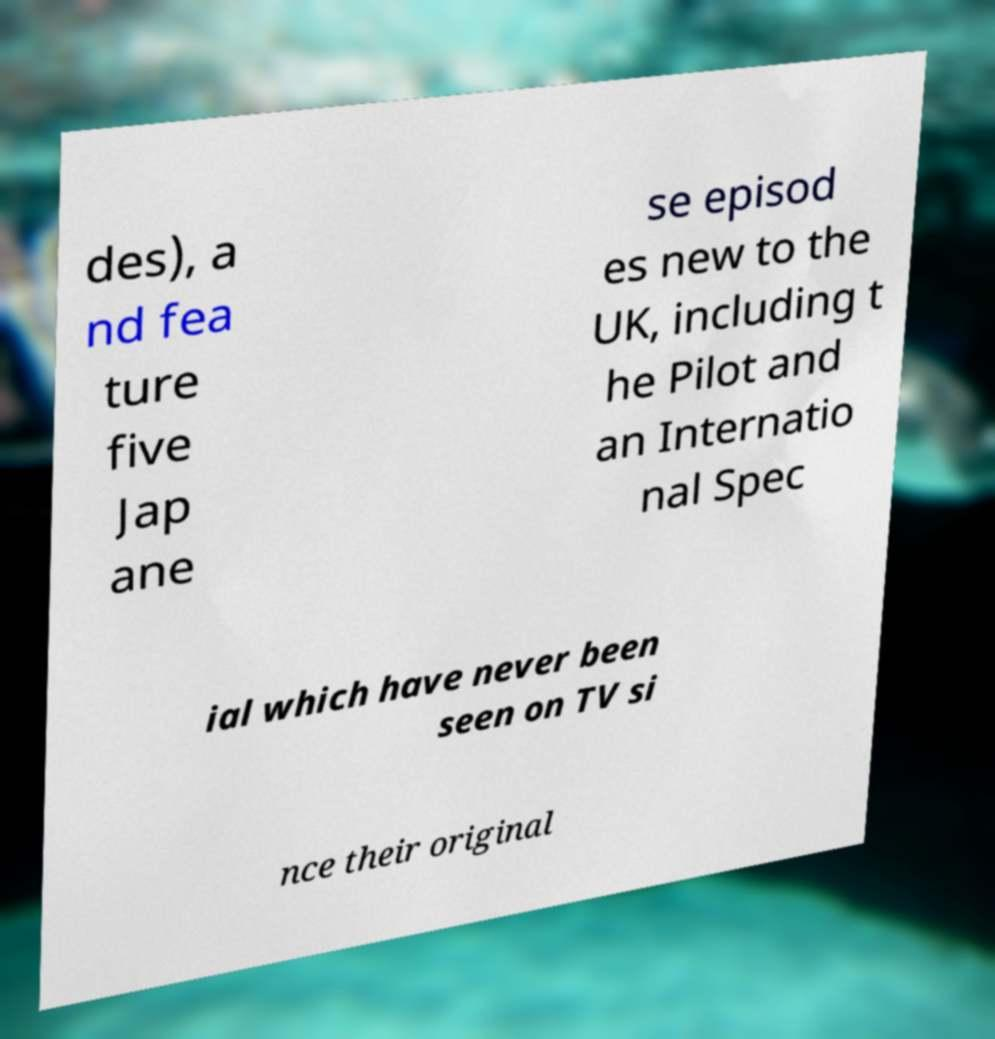Can you read and provide the text displayed in the image?This photo seems to have some interesting text. Can you extract and type it out for me? des), a nd fea ture five Jap ane se episod es new to the UK, including t he Pilot and an Internatio nal Spec ial which have never been seen on TV si nce their original 